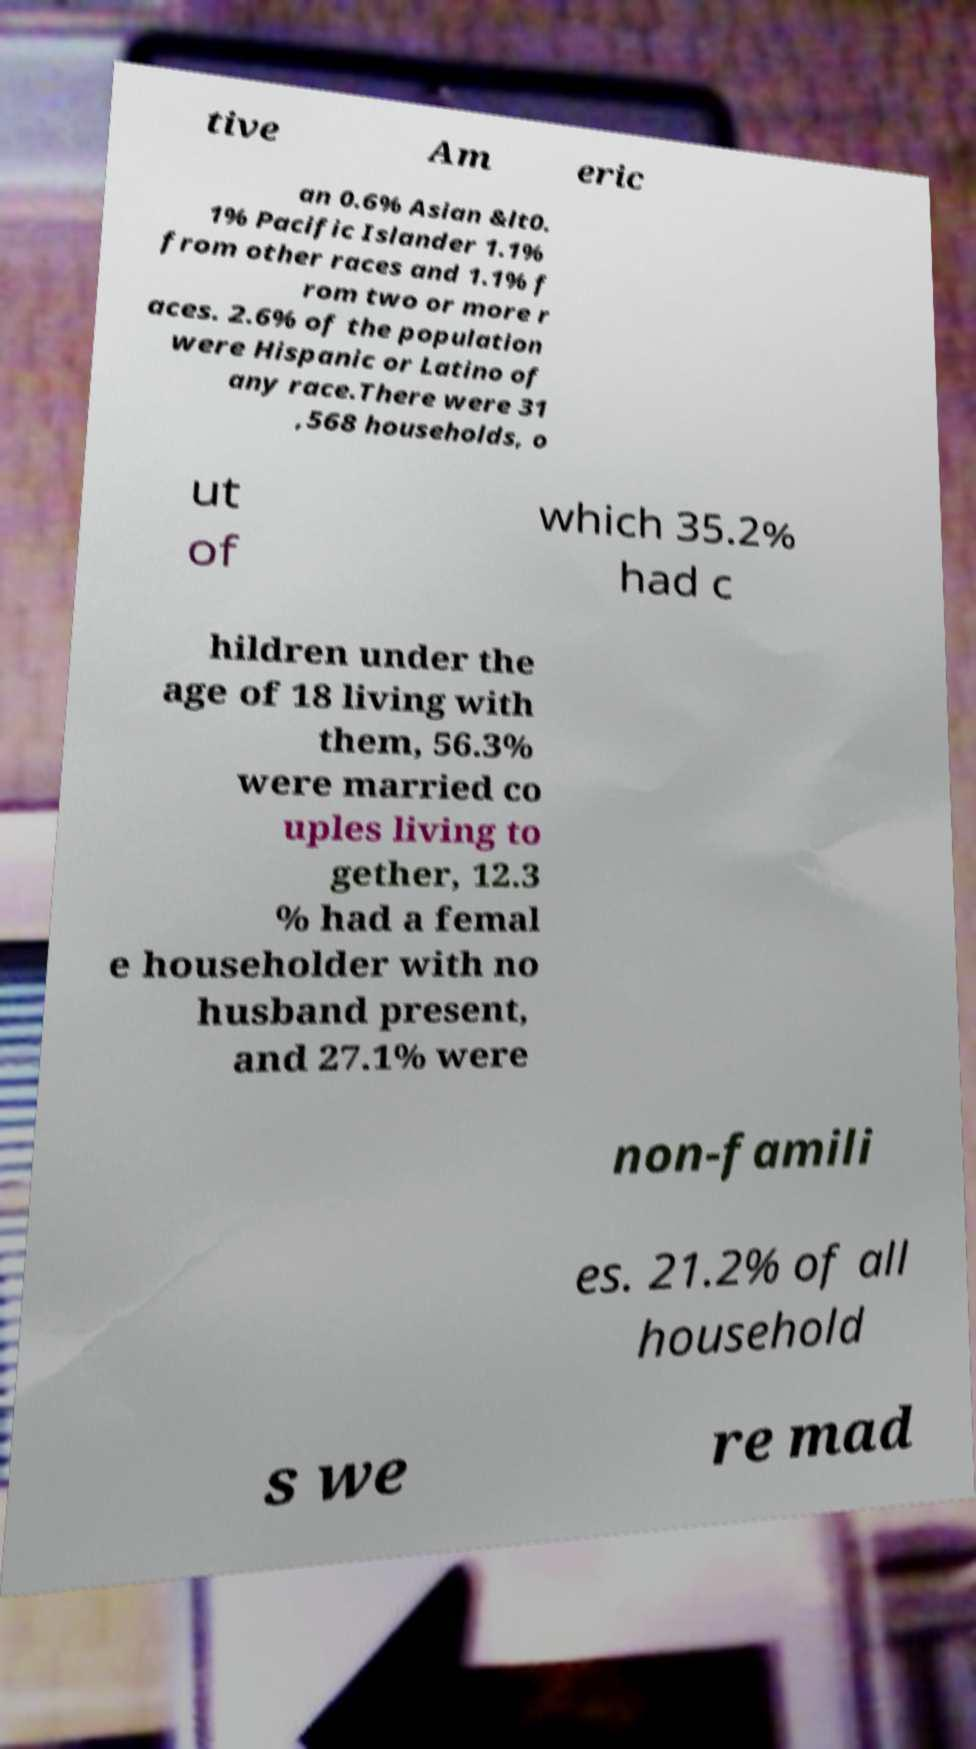Please identify and transcribe the text found in this image. tive Am eric an 0.6% Asian &lt0. 1% Pacific Islander 1.1% from other races and 1.1% f rom two or more r aces. 2.6% of the population were Hispanic or Latino of any race.There were 31 ,568 households, o ut of which 35.2% had c hildren under the age of 18 living with them, 56.3% were married co uples living to gether, 12.3 % had a femal e householder with no husband present, and 27.1% were non-famili es. 21.2% of all household s we re mad 